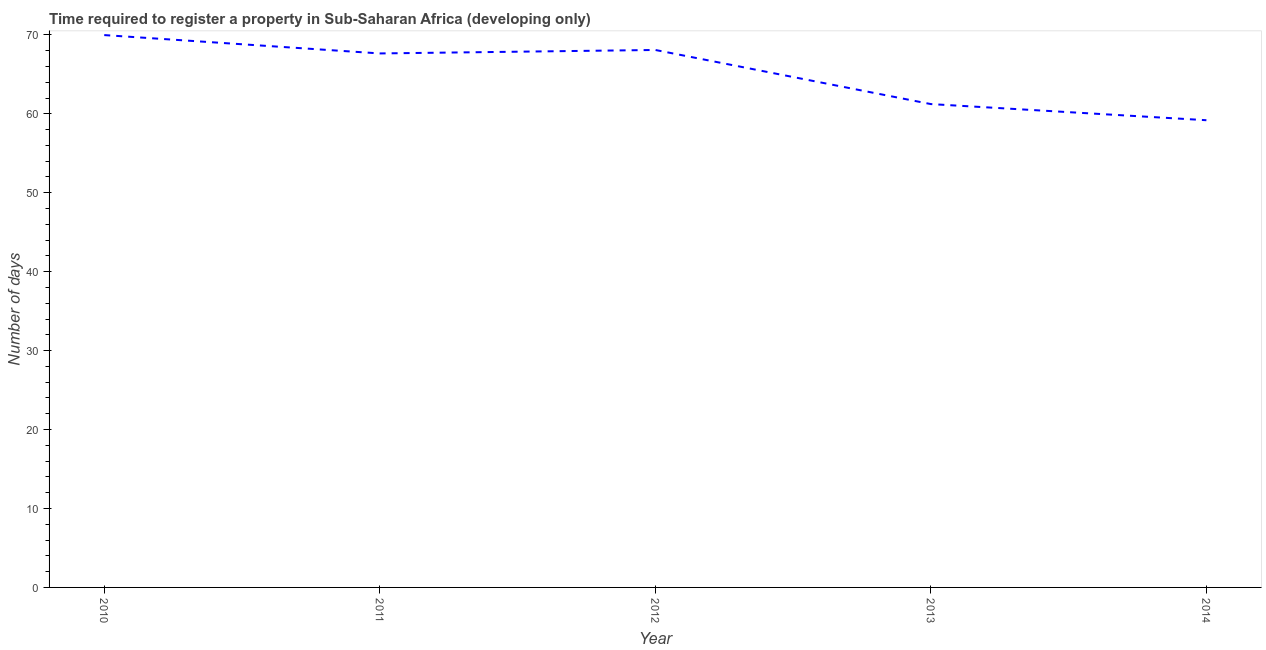What is the number of days required to register property in 2010?
Offer a very short reply. 69.98. Across all years, what is the maximum number of days required to register property?
Make the answer very short. 69.98. Across all years, what is the minimum number of days required to register property?
Keep it short and to the point. 59.19. What is the sum of the number of days required to register property?
Your answer should be very brief. 326.15. What is the difference between the number of days required to register property in 2011 and 2012?
Ensure brevity in your answer.  -0.44. What is the average number of days required to register property per year?
Offer a terse response. 65.23. What is the median number of days required to register property?
Ensure brevity in your answer.  67.65. In how many years, is the number of days required to register property greater than 18 days?
Offer a terse response. 5. What is the ratio of the number of days required to register property in 2011 to that in 2013?
Your response must be concise. 1.1. Is the number of days required to register property in 2011 less than that in 2014?
Make the answer very short. No. What is the difference between the highest and the second highest number of days required to register property?
Provide a succinct answer. 1.89. Is the sum of the number of days required to register property in 2011 and 2012 greater than the maximum number of days required to register property across all years?
Offer a terse response. Yes. What is the difference between the highest and the lowest number of days required to register property?
Keep it short and to the point. 10.79. In how many years, is the number of days required to register property greater than the average number of days required to register property taken over all years?
Your response must be concise. 3. How many lines are there?
Ensure brevity in your answer.  1. Are the values on the major ticks of Y-axis written in scientific E-notation?
Your response must be concise. No. Does the graph contain any zero values?
Offer a very short reply. No. What is the title of the graph?
Keep it short and to the point. Time required to register a property in Sub-Saharan Africa (developing only). What is the label or title of the Y-axis?
Offer a very short reply. Number of days. What is the Number of days of 2010?
Offer a terse response. 69.98. What is the Number of days of 2011?
Offer a terse response. 67.65. What is the Number of days of 2012?
Your response must be concise. 68.09. What is the Number of days in 2013?
Provide a short and direct response. 61.24. What is the Number of days in 2014?
Ensure brevity in your answer.  59.19. What is the difference between the Number of days in 2010 and 2011?
Your response must be concise. 2.33. What is the difference between the Number of days in 2010 and 2012?
Your response must be concise. 1.89. What is the difference between the Number of days in 2010 and 2013?
Offer a terse response. 8.74. What is the difference between the Number of days in 2010 and 2014?
Your response must be concise. 10.79. What is the difference between the Number of days in 2011 and 2012?
Keep it short and to the point. -0.44. What is the difference between the Number of days in 2011 and 2013?
Your answer should be compact. 6.42. What is the difference between the Number of days in 2011 and 2014?
Keep it short and to the point. 8.46. What is the difference between the Number of days in 2012 and 2013?
Ensure brevity in your answer.  6.86. What is the difference between the Number of days in 2012 and 2014?
Your answer should be compact. 8.9. What is the difference between the Number of days in 2013 and 2014?
Give a very brief answer. 2.04. What is the ratio of the Number of days in 2010 to that in 2011?
Ensure brevity in your answer.  1.03. What is the ratio of the Number of days in 2010 to that in 2012?
Your answer should be very brief. 1.03. What is the ratio of the Number of days in 2010 to that in 2013?
Make the answer very short. 1.14. What is the ratio of the Number of days in 2010 to that in 2014?
Provide a succinct answer. 1.18. What is the ratio of the Number of days in 2011 to that in 2012?
Ensure brevity in your answer.  0.99. What is the ratio of the Number of days in 2011 to that in 2013?
Give a very brief answer. 1.1. What is the ratio of the Number of days in 2011 to that in 2014?
Offer a very short reply. 1.14. What is the ratio of the Number of days in 2012 to that in 2013?
Offer a very short reply. 1.11. What is the ratio of the Number of days in 2012 to that in 2014?
Your answer should be compact. 1.15. What is the ratio of the Number of days in 2013 to that in 2014?
Your answer should be very brief. 1.03. 